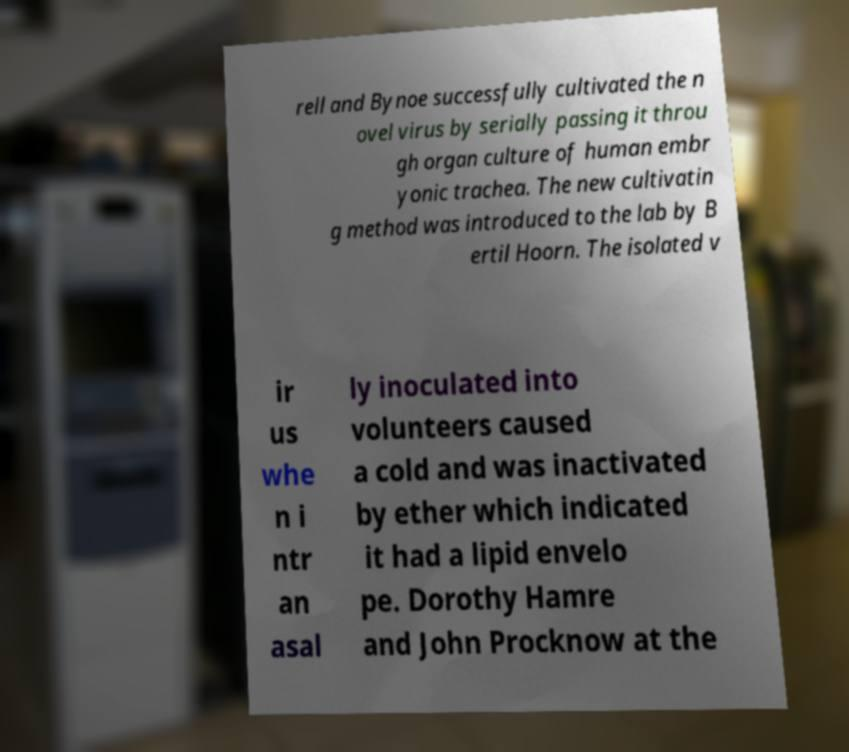There's text embedded in this image that I need extracted. Can you transcribe it verbatim? rell and Bynoe successfully cultivated the n ovel virus by serially passing it throu gh organ culture of human embr yonic trachea. The new cultivatin g method was introduced to the lab by B ertil Hoorn. The isolated v ir us whe n i ntr an asal ly inoculated into volunteers caused a cold and was inactivated by ether which indicated it had a lipid envelo pe. Dorothy Hamre and John Procknow at the 